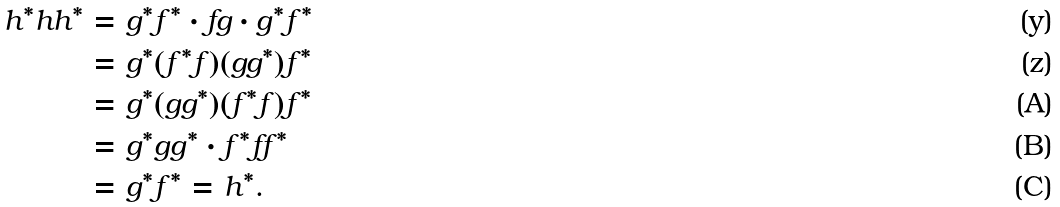<formula> <loc_0><loc_0><loc_500><loc_500>h ^ { * } h h ^ { * } & = g ^ { * } f ^ { * } \cdot f g \cdot g ^ { * } f ^ { * } \\ & = g ^ { * } ( f ^ { * } f ) ( g g ^ { * } ) f ^ { * } \\ & = g ^ { * } ( g g ^ { * } ) ( f ^ { * } f ) f ^ { * } \\ & = g ^ { * } g g ^ { * } \cdot f ^ { * } f f ^ { * } & & \\ & = g ^ { * } f ^ { * } = h ^ { * } .</formula> 